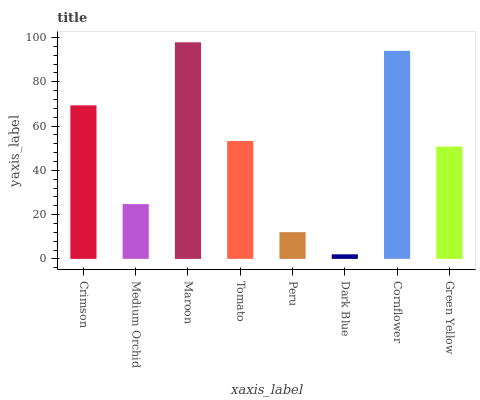Is Dark Blue the minimum?
Answer yes or no. Yes. Is Maroon the maximum?
Answer yes or no. Yes. Is Medium Orchid the minimum?
Answer yes or no. No. Is Medium Orchid the maximum?
Answer yes or no. No. Is Crimson greater than Medium Orchid?
Answer yes or no. Yes. Is Medium Orchid less than Crimson?
Answer yes or no. Yes. Is Medium Orchid greater than Crimson?
Answer yes or no. No. Is Crimson less than Medium Orchid?
Answer yes or no. No. Is Tomato the high median?
Answer yes or no. Yes. Is Green Yellow the low median?
Answer yes or no. Yes. Is Dark Blue the high median?
Answer yes or no. No. Is Peru the low median?
Answer yes or no. No. 